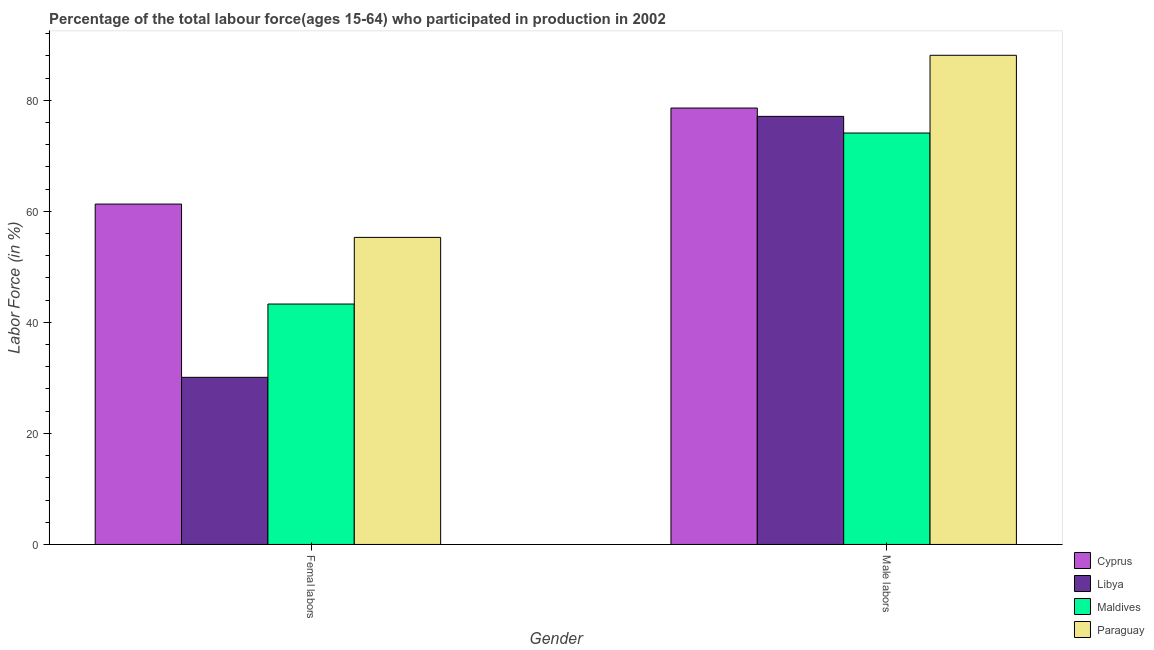How many bars are there on the 2nd tick from the left?
Keep it short and to the point. 4. What is the label of the 2nd group of bars from the left?
Provide a short and direct response. Male labors. What is the percentage of female labor force in Paraguay?
Provide a succinct answer. 55.3. Across all countries, what is the maximum percentage of female labor force?
Offer a very short reply. 61.3. Across all countries, what is the minimum percentage of male labour force?
Keep it short and to the point. 74.1. In which country was the percentage of female labor force maximum?
Your answer should be very brief. Cyprus. In which country was the percentage of female labor force minimum?
Your answer should be compact. Libya. What is the total percentage of female labor force in the graph?
Keep it short and to the point. 190. What is the difference between the percentage of female labor force in Cyprus and that in Maldives?
Your answer should be compact. 18. What is the difference between the percentage of male labour force in Maldives and the percentage of female labor force in Paraguay?
Provide a short and direct response. 18.8. What is the average percentage of female labor force per country?
Provide a short and direct response. 47.5. What is the difference between the percentage of male labour force and percentage of female labor force in Paraguay?
Keep it short and to the point. 32.8. What is the ratio of the percentage of female labor force in Paraguay to that in Libya?
Make the answer very short. 1.84. In how many countries, is the percentage of female labor force greater than the average percentage of female labor force taken over all countries?
Provide a short and direct response. 2. What does the 2nd bar from the left in Femal labors represents?
Your answer should be very brief. Libya. What does the 2nd bar from the right in Femal labors represents?
Your response must be concise. Maldives. Are all the bars in the graph horizontal?
Keep it short and to the point. No. What is the difference between two consecutive major ticks on the Y-axis?
Provide a succinct answer. 20. Are the values on the major ticks of Y-axis written in scientific E-notation?
Give a very brief answer. No. Does the graph contain any zero values?
Offer a very short reply. No. Where does the legend appear in the graph?
Your answer should be very brief. Bottom right. How are the legend labels stacked?
Provide a succinct answer. Vertical. What is the title of the graph?
Keep it short and to the point. Percentage of the total labour force(ages 15-64) who participated in production in 2002. What is the label or title of the Y-axis?
Ensure brevity in your answer.  Labor Force (in %). What is the Labor Force (in %) of Cyprus in Femal labors?
Offer a terse response. 61.3. What is the Labor Force (in %) in Libya in Femal labors?
Your response must be concise. 30.1. What is the Labor Force (in %) of Maldives in Femal labors?
Ensure brevity in your answer.  43.3. What is the Labor Force (in %) of Paraguay in Femal labors?
Your response must be concise. 55.3. What is the Labor Force (in %) in Cyprus in Male labors?
Give a very brief answer. 78.6. What is the Labor Force (in %) of Libya in Male labors?
Give a very brief answer. 77.1. What is the Labor Force (in %) in Maldives in Male labors?
Your response must be concise. 74.1. What is the Labor Force (in %) in Paraguay in Male labors?
Provide a short and direct response. 88.1. Across all Gender, what is the maximum Labor Force (in %) in Cyprus?
Offer a very short reply. 78.6. Across all Gender, what is the maximum Labor Force (in %) of Libya?
Make the answer very short. 77.1. Across all Gender, what is the maximum Labor Force (in %) in Maldives?
Offer a very short reply. 74.1. Across all Gender, what is the maximum Labor Force (in %) of Paraguay?
Offer a very short reply. 88.1. Across all Gender, what is the minimum Labor Force (in %) of Cyprus?
Your answer should be compact. 61.3. Across all Gender, what is the minimum Labor Force (in %) in Libya?
Offer a terse response. 30.1. Across all Gender, what is the minimum Labor Force (in %) in Maldives?
Ensure brevity in your answer.  43.3. Across all Gender, what is the minimum Labor Force (in %) of Paraguay?
Offer a very short reply. 55.3. What is the total Labor Force (in %) in Cyprus in the graph?
Give a very brief answer. 139.9. What is the total Labor Force (in %) of Libya in the graph?
Offer a very short reply. 107.2. What is the total Labor Force (in %) in Maldives in the graph?
Make the answer very short. 117.4. What is the total Labor Force (in %) of Paraguay in the graph?
Ensure brevity in your answer.  143.4. What is the difference between the Labor Force (in %) in Cyprus in Femal labors and that in Male labors?
Make the answer very short. -17.3. What is the difference between the Labor Force (in %) in Libya in Femal labors and that in Male labors?
Your response must be concise. -47. What is the difference between the Labor Force (in %) of Maldives in Femal labors and that in Male labors?
Offer a terse response. -30.8. What is the difference between the Labor Force (in %) in Paraguay in Femal labors and that in Male labors?
Your answer should be very brief. -32.8. What is the difference between the Labor Force (in %) of Cyprus in Femal labors and the Labor Force (in %) of Libya in Male labors?
Offer a terse response. -15.8. What is the difference between the Labor Force (in %) in Cyprus in Femal labors and the Labor Force (in %) in Maldives in Male labors?
Provide a short and direct response. -12.8. What is the difference between the Labor Force (in %) of Cyprus in Femal labors and the Labor Force (in %) of Paraguay in Male labors?
Provide a short and direct response. -26.8. What is the difference between the Labor Force (in %) in Libya in Femal labors and the Labor Force (in %) in Maldives in Male labors?
Your response must be concise. -44. What is the difference between the Labor Force (in %) in Libya in Femal labors and the Labor Force (in %) in Paraguay in Male labors?
Your answer should be compact. -58. What is the difference between the Labor Force (in %) of Maldives in Femal labors and the Labor Force (in %) of Paraguay in Male labors?
Your answer should be compact. -44.8. What is the average Labor Force (in %) in Cyprus per Gender?
Your answer should be very brief. 69.95. What is the average Labor Force (in %) in Libya per Gender?
Provide a succinct answer. 53.6. What is the average Labor Force (in %) of Maldives per Gender?
Your answer should be compact. 58.7. What is the average Labor Force (in %) of Paraguay per Gender?
Give a very brief answer. 71.7. What is the difference between the Labor Force (in %) in Cyprus and Labor Force (in %) in Libya in Femal labors?
Give a very brief answer. 31.2. What is the difference between the Labor Force (in %) of Cyprus and Labor Force (in %) of Maldives in Femal labors?
Offer a very short reply. 18. What is the difference between the Labor Force (in %) in Cyprus and Labor Force (in %) in Paraguay in Femal labors?
Keep it short and to the point. 6. What is the difference between the Labor Force (in %) of Libya and Labor Force (in %) of Paraguay in Femal labors?
Your response must be concise. -25.2. What is the difference between the Labor Force (in %) of Cyprus and Labor Force (in %) of Libya in Male labors?
Your answer should be very brief. 1.5. What is the difference between the Labor Force (in %) in Cyprus and Labor Force (in %) in Maldives in Male labors?
Your answer should be compact. 4.5. What is the difference between the Labor Force (in %) in Libya and Labor Force (in %) in Paraguay in Male labors?
Provide a short and direct response. -11. What is the ratio of the Labor Force (in %) of Cyprus in Femal labors to that in Male labors?
Provide a short and direct response. 0.78. What is the ratio of the Labor Force (in %) in Libya in Femal labors to that in Male labors?
Your response must be concise. 0.39. What is the ratio of the Labor Force (in %) in Maldives in Femal labors to that in Male labors?
Offer a very short reply. 0.58. What is the ratio of the Labor Force (in %) in Paraguay in Femal labors to that in Male labors?
Keep it short and to the point. 0.63. What is the difference between the highest and the second highest Labor Force (in %) of Maldives?
Your answer should be very brief. 30.8. What is the difference between the highest and the second highest Labor Force (in %) of Paraguay?
Your answer should be compact. 32.8. What is the difference between the highest and the lowest Labor Force (in %) in Cyprus?
Provide a short and direct response. 17.3. What is the difference between the highest and the lowest Labor Force (in %) of Libya?
Your answer should be very brief. 47. What is the difference between the highest and the lowest Labor Force (in %) in Maldives?
Offer a terse response. 30.8. What is the difference between the highest and the lowest Labor Force (in %) in Paraguay?
Your answer should be compact. 32.8. 